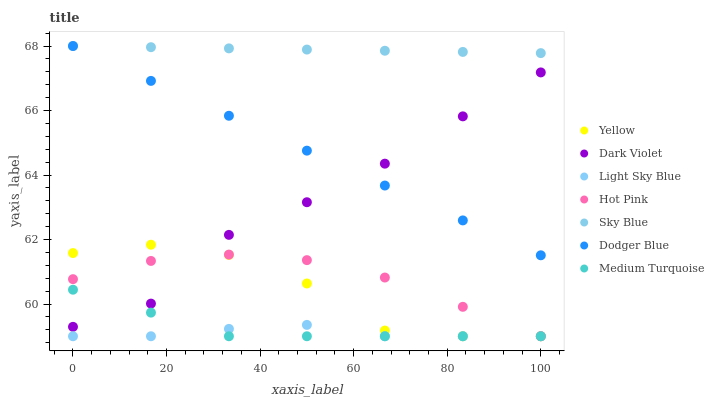Does Light Sky Blue have the minimum area under the curve?
Answer yes or no. Yes. Does Sky Blue have the maximum area under the curve?
Answer yes or no. Yes. Does Dark Violet have the minimum area under the curve?
Answer yes or no. No. Does Dark Violet have the maximum area under the curve?
Answer yes or no. No. Is Dodger Blue the smoothest?
Answer yes or no. Yes. Is Yellow the roughest?
Answer yes or no. Yes. Is Dark Violet the smoothest?
Answer yes or no. No. Is Dark Violet the roughest?
Answer yes or no. No. Does Hot Pink have the lowest value?
Answer yes or no. Yes. Does Dark Violet have the lowest value?
Answer yes or no. No. Does Sky Blue have the highest value?
Answer yes or no. Yes. Does Dark Violet have the highest value?
Answer yes or no. No. Is Medium Turquoise less than Sky Blue?
Answer yes or no. Yes. Is Dodger Blue greater than Medium Turquoise?
Answer yes or no. Yes. Does Dodger Blue intersect Dark Violet?
Answer yes or no. Yes. Is Dodger Blue less than Dark Violet?
Answer yes or no. No. Is Dodger Blue greater than Dark Violet?
Answer yes or no. No. Does Medium Turquoise intersect Sky Blue?
Answer yes or no. No. 